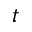<formula> <loc_0><loc_0><loc_500><loc_500>t</formula> 